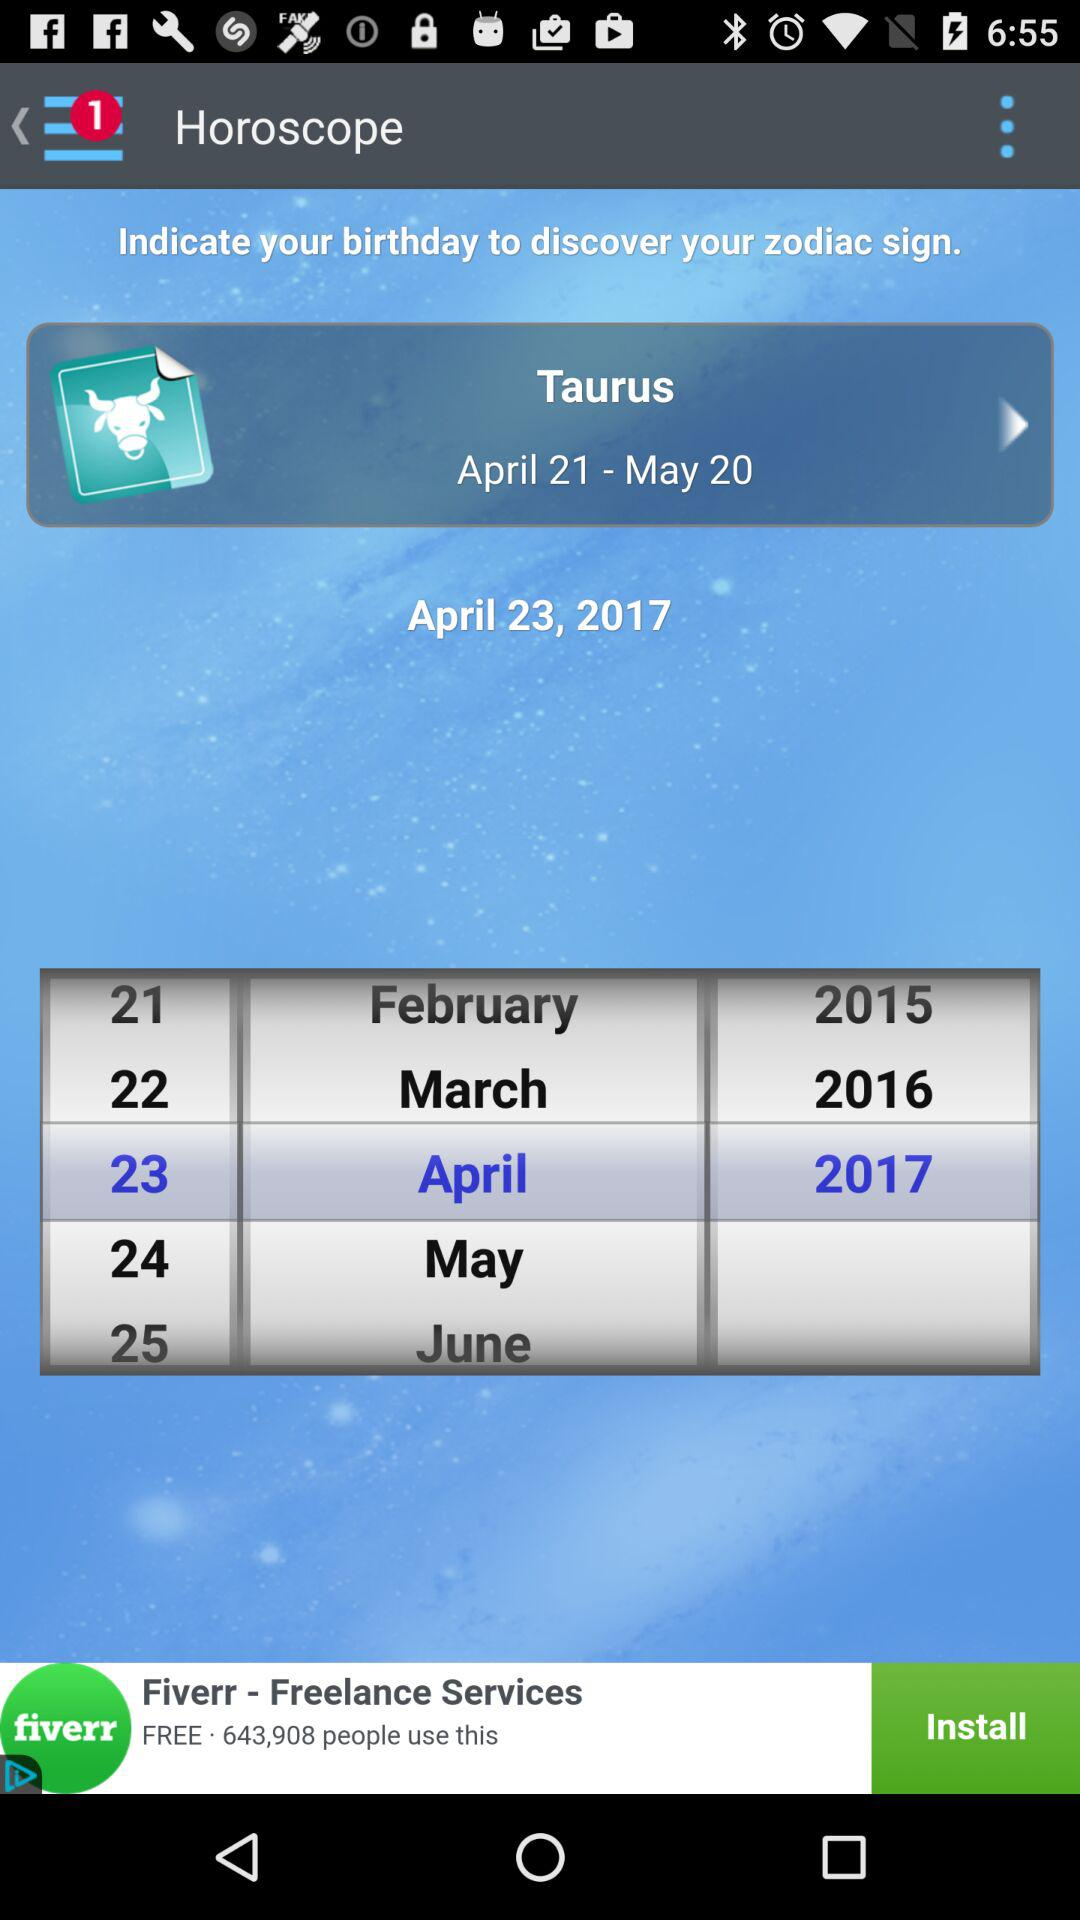What is the selected date? The selected date is April 23, 2017. 